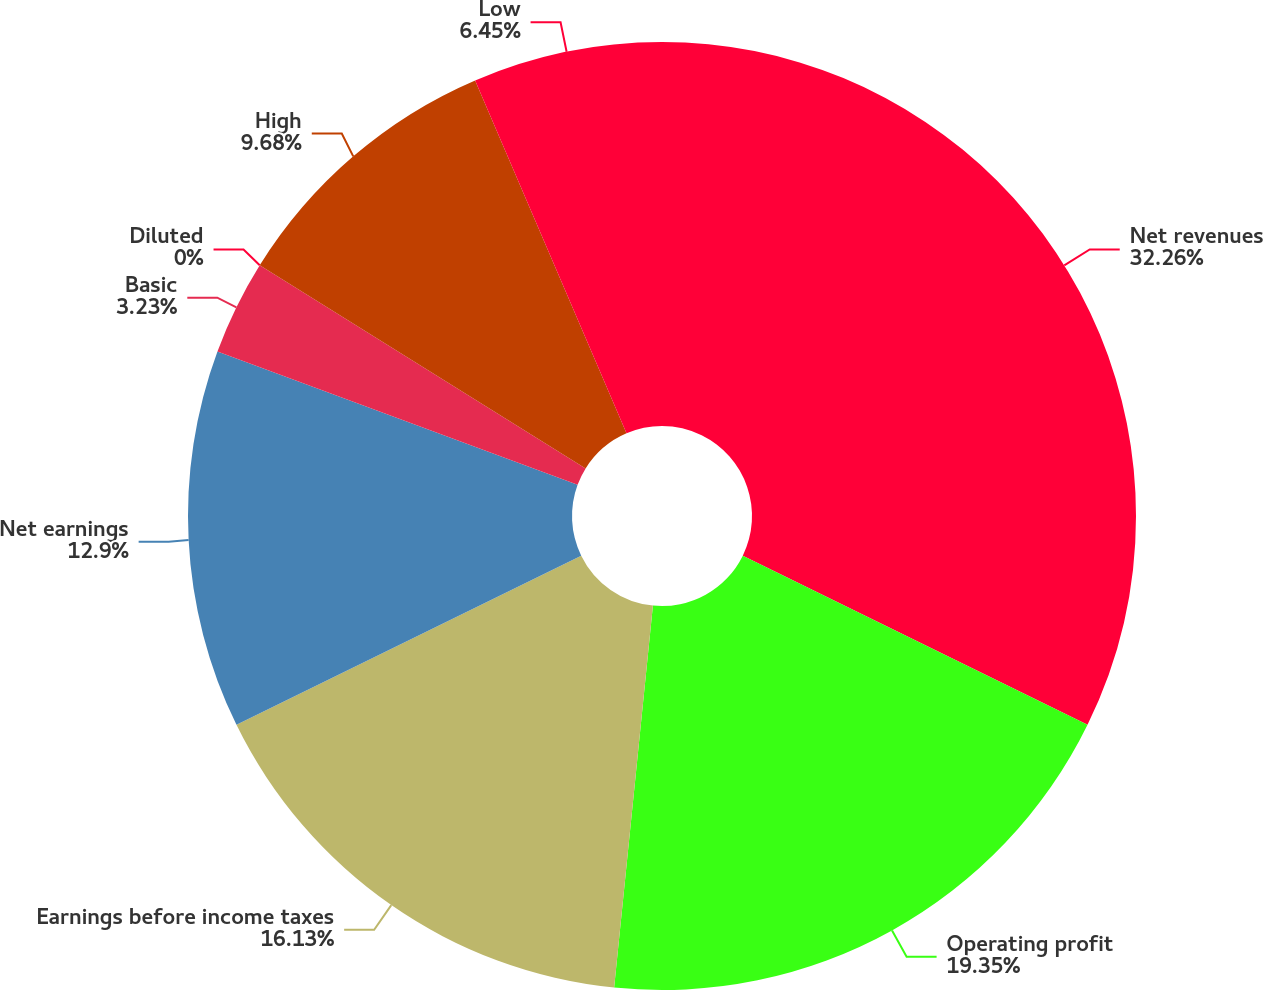Convert chart to OTSL. <chart><loc_0><loc_0><loc_500><loc_500><pie_chart><fcel>Net revenues<fcel>Operating profit<fcel>Earnings before income taxes<fcel>Net earnings<fcel>Basic<fcel>Diluted<fcel>High<fcel>Low<nl><fcel>32.26%<fcel>19.35%<fcel>16.13%<fcel>12.9%<fcel>3.23%<fcel>0.0%<fcel>9.68%<fcel>6.45%<nl></chart> 